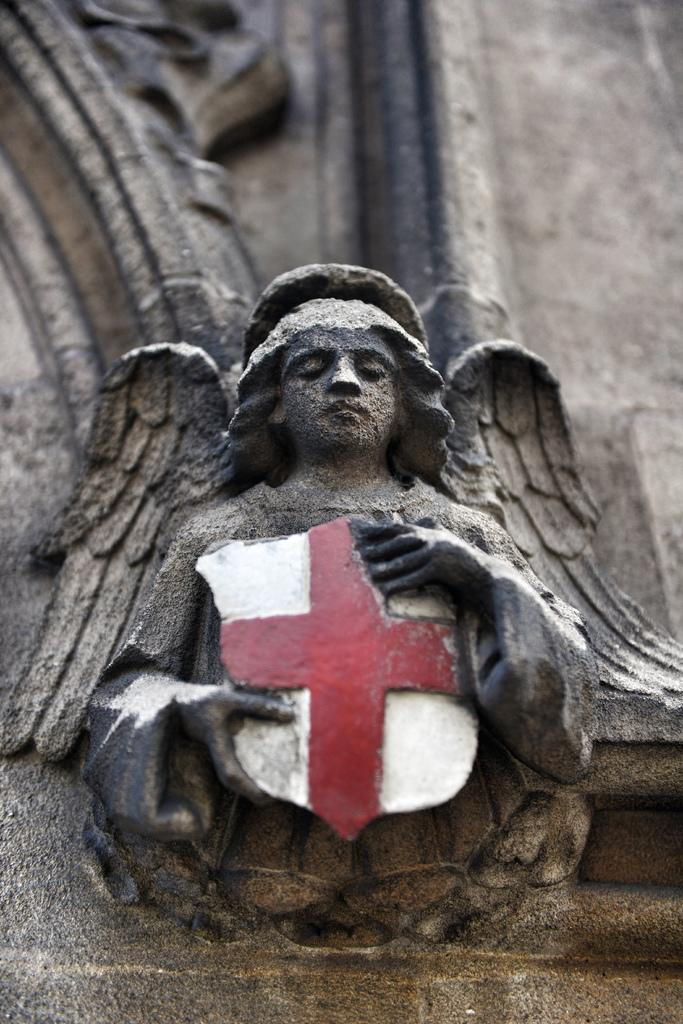What is the main subject of the image? The main subject of the image is a statue. Can you describe the statue in the image? The statue is of a person, and it is holding a cross symbol. How many sheep are present in the image? There are no sheep present in the image; it features a statue of a person holding a cross symbol. What type of peace symbol can be seen in the image? There is no peace symbol present in the image; it features a statue of a person holding a cross symbol. 